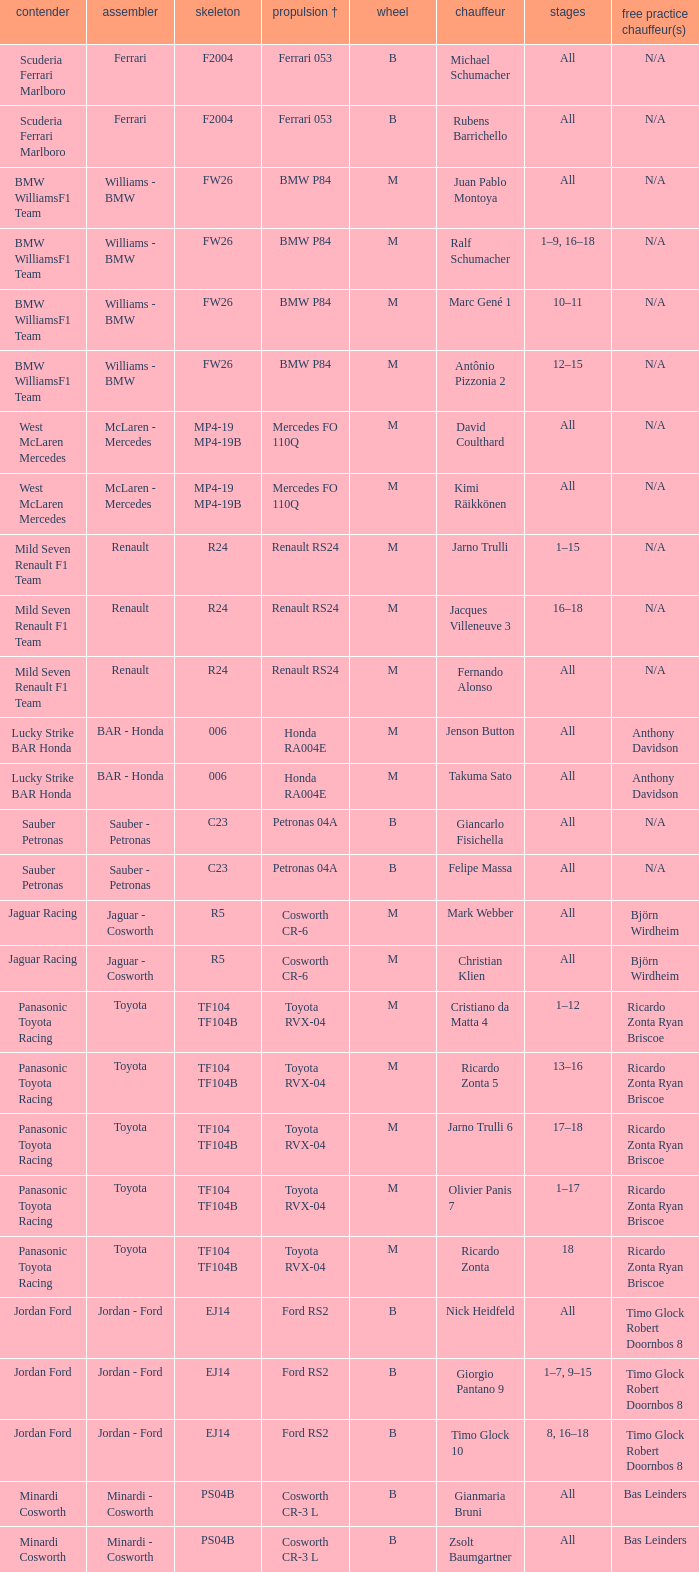What kind of free practice is there with a Ford RS2 engine +? Timo Glock Robert Doornbos 8, Timo Glock Robert Doornbos 8, Timo Glock Robert Doornbos 8. 